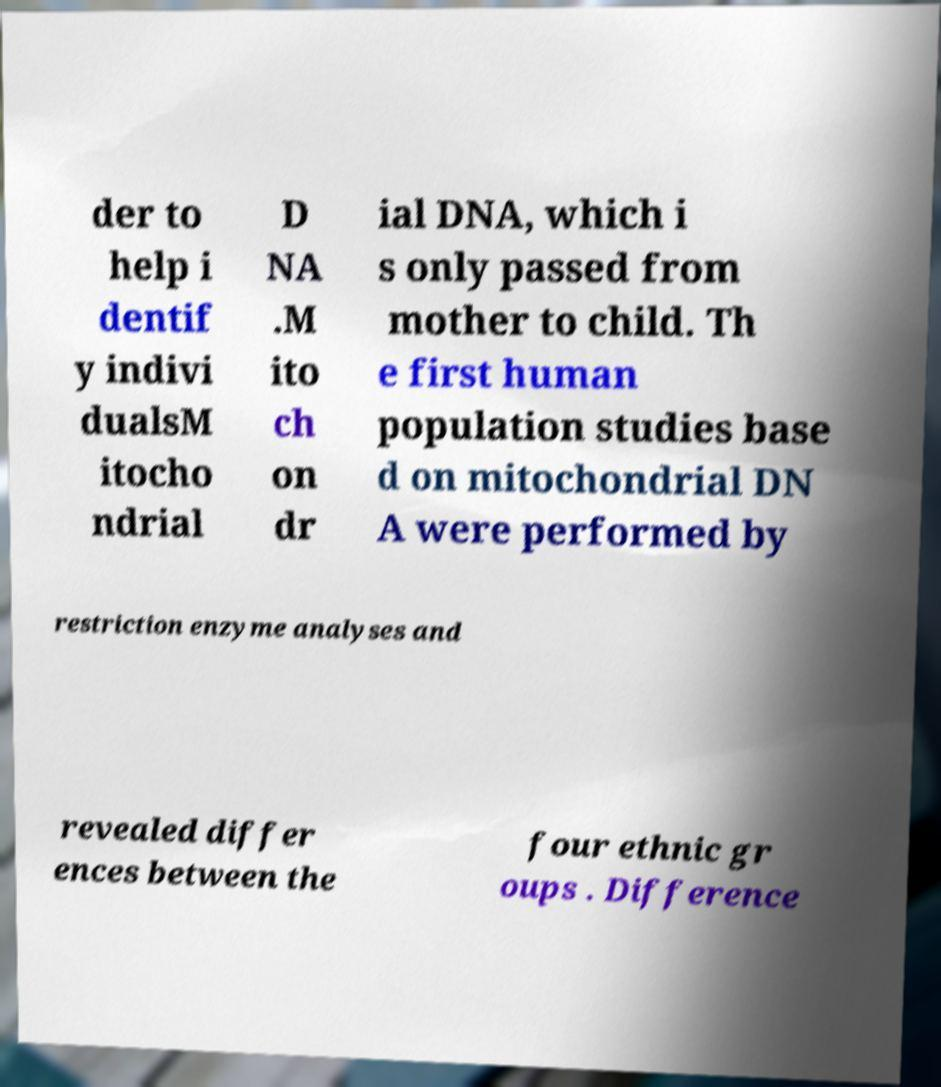Please identify and transcribe the text found in this image. der to help i dentif y indivi dualsM itocho ndrial D NA .M ito ch on dr ial DNA, which i s only passed from mother to child. Th e first human population studies base d on mitochondrial DN A were performed by restriction enzyme analyses and revealed differ ences between the four ethnic gr oups . Difference 